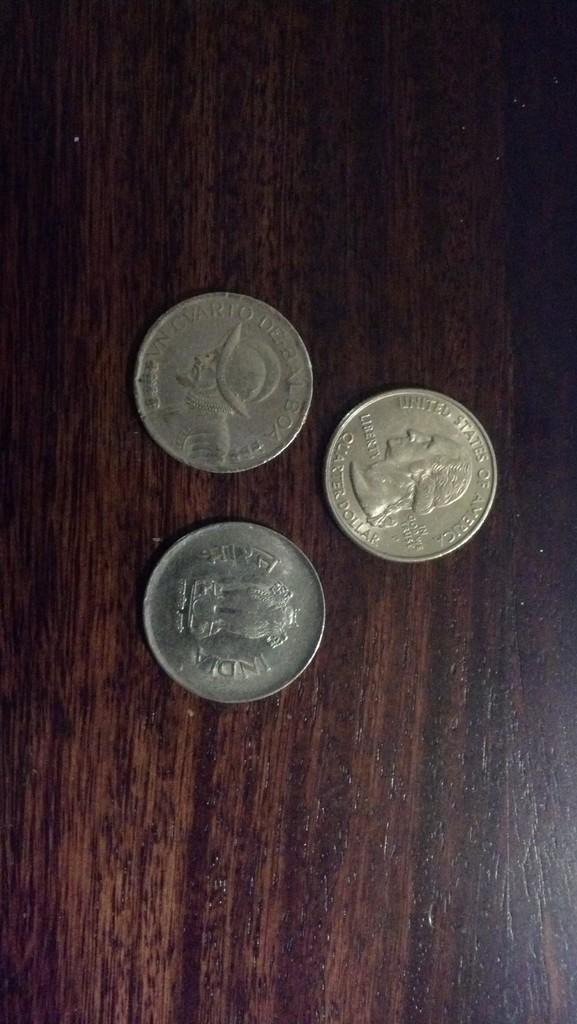<image>
Render a clear and concise summary of the photo. three quarters with the words 'united states of america' on them 